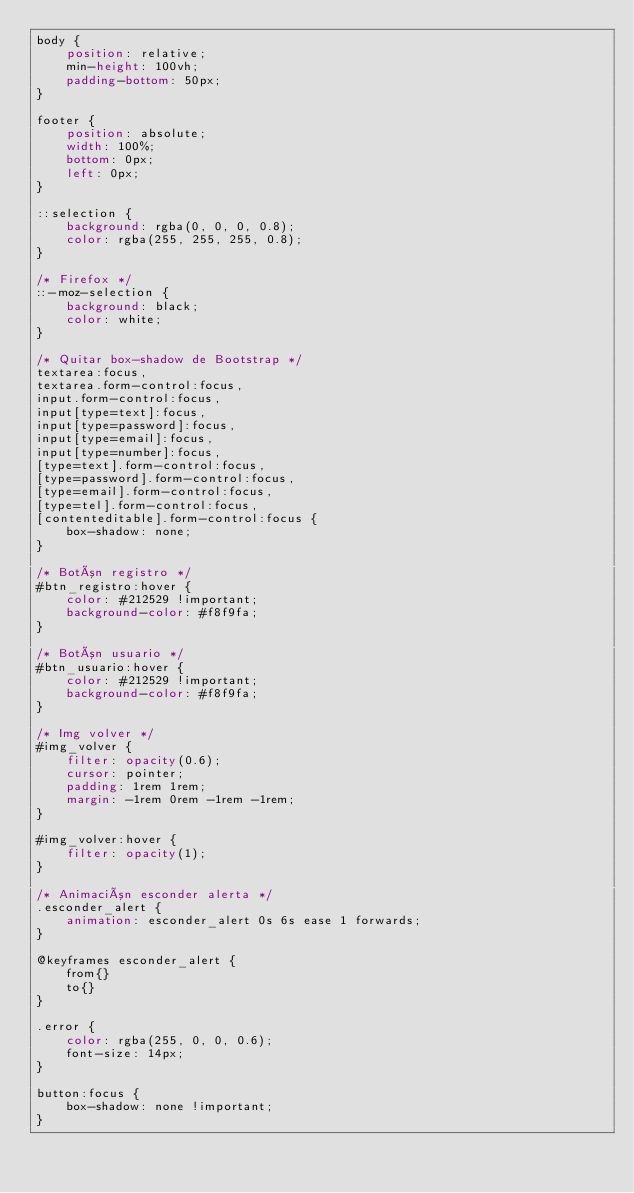<code> <loc_0><loc_0><loc_500><loc_500><_CSS_>body {
    position: relative;
    min-height: 100vh;
    padding-bottom: 50px;
}

footer {
    position: absolute;
    width: 100%;
    bottom: 0px;
    left: 0px;
}

::selection {
    background: rgba(0, 0, 0, 0.8);
    color: rgba(255, 255, 255, 0.8);
}

/* Firefox */
::-moz-selection {
    background: black;
    color: white;
}

/* Quitar box-shadow de Bootstrap */
textarea:focus,
textarea.form-control:focus,
input.form-control:focus,
input[type=text]:focus,
input[type=password]:focus,
input[type=email]:focus,
input[type=number]:focus,
[type=text].form-control:focus,
[type=password].form-control:focus,
[type=email].form-control:focus,
[type=tel].form-control:focus,
[contenteditable].form-control:focus {
    box-shadow: none;
}

/* Botón registro */
#btn_registro:hover {
    color: #212529 !important;
    background-color: #f8f9fa;
}

/* Botón usuario */
#btn_usuario:hover {
    color: #212529 !important;
    background-color: #f8f9fa;
}

/* Img volver */
#img_volver {
    filter: opacity(0.6);
    cursor: pointer;
    padding: 1rem 1rem;
    margin: -1rem 0rem -1rem -1rem;
}

#img_volver:hover {
    filter: opacity(1);
}

/* Animación esconder alerta */
.esconder_alert {
    animation: esconder_alert 0s 6s ease 1 forwards;
}

@keyframes esconder_alert {
    from{}
    to{}
}

.error {
    color: rgba(255, 0, 0, 0.6);
    font-size: 14px;
}

button:focus {
    box-shadow: none !important;
}</code> 